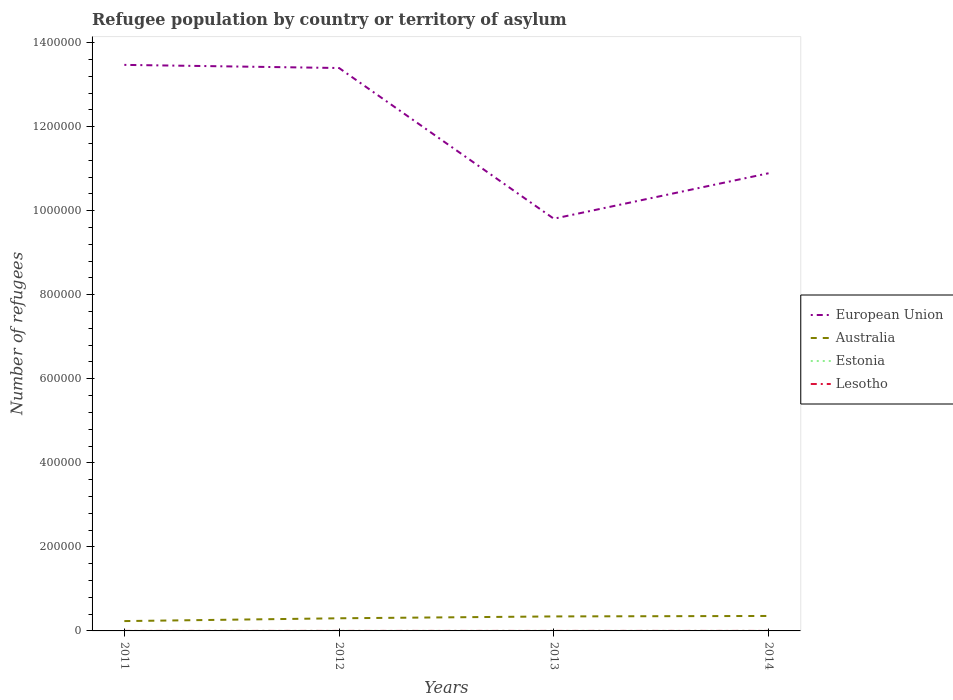How many different coloured lines are there?
Your answer should be very brief. 4. Does the line corresponding to Lesotho intersect with the line corresponding to European Union?
Provide a short and direct response. No. Across all years, what is the maximum number of refugees in European Union?
Give a very brief answer. 9.81e+05. In which year was the number of refugees in Estonia maximum?
Offer a terse response. 2011. What is the total number of refugees in Australia in the graph?
Offer a terse response. -6649. What is the difference between the highest and the lowest number of refugees in Lesotho?
Make the answer very short. 1. Is the number of refugees in Estonia strictly greater than the number of refugees in Lesotho over the years?
Offer a very short reply. No. How many lines are there?
Offer a very short reply. 4. Are the values on the major ticks of Y-axis written in scientific E-notation?
Your answer should be compact. No. Does the graph contain any zero values?
Make the answer very short. No. How many legend labels are there?
Provide a succinct answer. 4. How are the legend labels stacked?
Ensure brevity in your answer.  Vertical. What is the title of the graph?
Provide a succinct answer. Refugee population by country or territory of asylum. What is the label or title of the Y-axis?
Your answer should be compact. Number of refugees. What is the Number of refugees of European Union in 2011?
Give a very brief answer. 1.35e+06. What is the Number of refugees of Australia in 2011?
Your answer should be compact. 2.34e+04. What is the Number of refugees in Estonia in 2011?
Ensure brevity in your answer.  50. What is the Number of refugees of Lesotho in 2011?
Offer a very short reply. 34. What is the Number of refugees in European Union in 2012?
Your answer should be compact. 1.34e+06. What is the Number of refugees of Australia in 2012?
Ensure brevity in your answer.  3.01e+04. What is the Number of refugees in Estonia in 2012?
Offer a very short reply. 63. What is the Number of refugees of Lesotho in 2012?
Your answer should be compact. 34. What is the Number of refugees of European Union in 2013?
Your answer should be compact. 9.81e+05. What is the Number of refugees in Australia in 2013?
Make the answer very short. 3.45e+04. What is the Number of refugees in Estonia in 2013?
Provide a short and direct response. 70. What is the Number of refugees in European Union in 2014?
Ensure brevity in your answer.  1.09e+06. What is the Number of refugees of Australia in 2014?
Make the answer very short. 3.56e+04. Across all years, what is the maximum Number of refugees in European Union?
Provide a short and direct response. 1.35e+06. Across all years, what is the maximum Number of refugees of Australia?
Offer a terse response. 3.56e+04. Across all years, what is the minimum Number of refugees of European Union?
Provide a short and direct response. 9.81e+05. Across all years, what is the minimum Number of refugees in Australia?
Ensure brevity in your answer.  2.34e+04. What is the total Number of refugees in European Union in the graph?
Your answer should be compact. 4.76e+06. What is the total Number of refugees in Australia in the graph?
Your answer should be very brief. 1.24e+05. What is the total Number of refugees of Estonia in the graph?
Offer a very short reply. 273. What is the total Number of refugees of Lesotho in the graph?
Make the answer very short. 142. What is the difference between the Number of refugees in European Union in 2011 and that in 2012?
Keep it short and to the point. 7465. What is the difference between the Number of refugees of Australia in 2011 and that in 2012?
Make the answer very short. -6649. What is the difference between the Number of refugees of Estonia in 2011 and that in 2012?
Provide a succinct answer. -13. What is the difference between the Number of refugees of European Union in 2011 and that in 2013?
Offer a terse response. 3.66e+05. What is the difference between the Number of refugees of Australia in 2011 and that in 2013?
Your answer should be very brief. -1.11e+04. What is the difference between the Number of refugees of Lesotho in 2011 and that in 2013?
Give a very brief answer. 4. What is the difference between the Number of refugees of European Union in 2011 and that in 2014?
Offer a terse response. 2.58e+05. What is the difference between the Number of refugees in Australia in 2011 and that in 2014?
Ensure brevity in your answer.  -1.21e+04. What is the difference between the Number of refugees in Estonia in 2011 and that in 2014?
Offer a very short reply. -40. What is the difference between the Number of refugees of Lesotho in 2011 and that in 2014?
Your answer should be compact. -10. What is the difference between the Number of refugees of European Union in 2012 and that in 2013?
Keep it short and to the point. 3.59e+05. What is the difference between the Number of refugees in Australia in 2012 and that in 2013?
Provide a short and direct response. -4420. What is the difference between the Number of refugees of European Union in 2012 and that in 2014?
Provide a succinct answer. 2.50e+05. What is the difference between the Number of refugees in Australia in 2012 and that in 2014?
Give a very brief answer. -5499. What is the difference between the Number of refugees of European Union in 2013 and that in 2014?
Keep it short and to the point. -1.08e+05. What is the difference between the Number of refugees of Australia in 2013 and that in 2014?
Offer a very short reply. -1079. What is the difference between the Number of refugees in European Union in 2011 and the Number of refugees in Australia in 2012?
Make the answer very short. 1.32e+06. What is the difference between the Number of refugees of European Union in 2011 and the Number of refugees of Estonia in 2012?
Your answer should be compact. 1.35e+06. What is the difference between the Number of refugees of European Union in 2011 and the Number of refugees of Lesotho in 2012?
Your answer should be very brief. 1.35e+06. What is the difference between the Number of refugees of Australia in 2011 and the Number of refugees of Estonia in 2012?
Offer a very short reply. 2.34e+04. What is the difference between the Number of refugees in Australia in 2011 and the Number of refugees in Lesotho in 2012?
Make the answer very short. 2.34e+04. What is the difference between the Number of refugees in European Union in 2011 and the Number of refugees in Australia in 2013?
Provide a succinct answer. 1.31e+06. What is the difference between the Number of refugees of European Union in 2011 and the Number of refugees of Estonia in 2013?
Provide a succinct answer. 1.35e+06. What is the difference between the Number of refugees of European Union in 2011 and the Number of refugees of Lesotho in 2013?
Your answer should be very brief. 1.35e+06. What is the difference between the Number of refugees in Australia in 2011 and the Number of refugees in Estonia in 2013?
Give a very brief answer. 2.34e+04. What is the difference between the Number of refugees of Australia in 2011 and the Number of refugees of Lesotho in 2013?
Give a very brief answer. 2.34e+04. What is the difference between the Number of refugees in European Union in 2011 and the Number of refugees in Australia in 2014?
Ensure brevity in your answer.  1.31e+06. What is the difference between the Number of refugees in European Union in 2011 and the Number of refugees in Estonia in 2014?
Offer a terse response. 1.35e+06. What is the difference between the Number of refugees of European Union in 2011 and the Number of refugees of Lesotho in 2014?
Provide a succinct answer. 1.35e+06. What is the difference between the Number of refugees in Australia in 2011 and the Number of refugees in Estonia in 2014?
Provide a short and direct response. 2.33e+04. What is the difference between the Number of refugees of Australia in 2011 and the Number of refugees of Lesotho in 2014?
Your answer should be compact. 2.34e+04. What is the difference between the Number of refugees in European Union in 2012 and the Number of refugees in Australia in 2013?
Offer a terse response. 1.31e+06. What is the difference between the Number of refugees of European Union in 2012 and the Number of refugees of Estonia in 2013?
Provide a short and direct response. 1.34e+06. What is the difference between the Number of refugees in European Union in 2012 and the Number of refugees in Lesotho in 2013?
Give a very brief answer. 1.34e+06. What is the difference between the Number of refugees of Australia in 2012 and the Number of refugees of Estonia in 2013?
Keep it short and to the point. 3.00e+04. What is the difference between the Number of refugees in Australia in 2012 and the Number of refugees in Lesotho in 2013?
Your response must be concise. 3.01e+04. What is the difference between the Number of refugees in European Union in 2012 and the Number of refugees in Australia in 2014?
Ensure brevity in your answer.  1.30e+06. What is the difference between the Number of refugees in European Union in 2012 and the Number of refugees in Estonia in 2014?
Ensure brevity in your answer.  1.34e+06. What is the difference between the Number of refugees in European Union in 2012 and the Number of refugees in Lesotho in 2014?
Provide a succinct answer. 1.34e+06. What is the difference between the Number of refugees of Australia in 2012 and the Number of refugees of Estonia in 2014?
Make the answer very short. 3.00e+04. What is the difference between the Number of refugees of Australia in 2012 and the Number of refugees of Lesotho in 2014?
Make the answer very short. 3.00e+04. What is the difference between the Number of refugees of Estonia in 2012 and the Number of refugees of Lesotho in 2014?
Offer a very short reply. 19. What is the difference between the Number of refugees of European Union in 2013 and the Number of refugees of Australia in 2014?
Keep it short and to the point. 9.45e+05. What is the difference between the Number of refugees in European Union in 2013 and the Number of refugees in Estonia in 2014?
Your answer should be compact. 9.81e+05. What is the difference between the Number of refugees of European Union in 2013 and the Number of refugees of Lesotho in 2014?
Keep it short and to the point. 9.81e+05. What is the difference between the Number of refugees in Australia in 2013 and the Number of refugees in Estonia in 2014?
Provide a succinct answer. 3.44e+04. What is the difference between the Number of refugees in Australia in 2013 and the Number of refugees in Lesotho in 2014?
Your answer should be very brief. 3.45e+04. What is the difference between the Number of refugees in Estonia in 2013 and the Number of refugees in Lesotho in 2014?
Give a very brief answer. 26. What is the average Number of refugees of European Union per year?
Provide a short and direct response. 1.19e+06. What is the average Number of refugees in Australia per year?
Give a very brief answer. 3.09e+04. What is the average Number of refugees of Estonia per year?
Your answer should be very brief. 68.25. What is the average Number of refugees in Lesotho per year?
Your response must be concise. 35.5. In the year 2011, what is the difference between the Number of refugees in European Union and Number of refugees in Australia?
Provide a succinct answer. 1.32e+06. In the year 2011, what is the difference between the Number of refugees in European Union and Number of refugees in Estonia?
Offer a very short reply. 1.35e+06. In the year 2011, what is the difference between the Number of refugees in European Union and Number of refugees in Lesotho?
Your answer should be compact. 1.35e+06. In the year 2011, what is the difference between the Number of refugees in Australia and Number of refugees in Estonia?
Give a very brief answer. 2.34e+04. In the year 2011, what is the difference between the Number of refugees in Australia and Number of refugees in Lesotho?
Ensure brevity in your answer.  2.34e+04. In the year 2011, what is the difference between the Number of refugees of Estonia and Number of refugees of Lesotho?
Provide a succinct answer. 16. In the year 2012, what is the difference between the Number of refugees in European Union and Number of refugees in Australia?
Offer a terse response. 1.31e+06. In the year 2012, what is the difference between the Number of refugees in European Union and Number of refugees in Estonia?
Provide a short and direct response. 1.34e+06. In the year 2012, what is the difference between the Number of refugees in European Union and Number of refugees in Lesotho?
Your answer should be very brief. 1.34e+06. In the year 2012, what is the difference between the Number of refugees in Australia and Number of refugees in Estonia?
Your answer should be very brief. 3.00e+04. In the year 2012, what is the difference between the Number of refugees in Australia and Number of refugees in Lesotho?
Ensure brevity in your answer.  3.00e+04. In the year 2012, what is the difference between the Number of refugees in Estonia and Number of refugees in Lesotho?
Keep it short and to the point. 29. In the year 2013, what is the difference between the Number of refugees in European Union and Number of refugees in Australia?
Provide a succinct answer. 9.46e+05. In the year 2013, what is the difference between the Number of refugees of European Union and Number of refugees of Estonia?
Ensure brevity in your answer.  9.81e+05. In the year 2013, what is the difference between the Number of refugees of European Union and Number of refugees of Lesotho?
Keep it short and to the point. 9.81e+05. In the year 2013, what is the difference between the Number of refugees of Australia and Number of refugees of Estonia?
Provide a short and direct response. 3.44e+04. In the year 2013, what is the difference between the Number of refugees in Australia and Number of refugees in Lesotho?
Give a very brief answer. 3.45e+04. In the year 2014, what is the difference between the Number of refugees in European Union and Number of refugees in Australia?
Offer a very short reply. 1.05e+06. In the year 2014, what is the difference between the Number of refugees of European Union and Number of refugees of Estonia?
Give a very brief answer. 1.09e+06. In the year 2014, what is the difference between the Number of refugees in European Union and Number of refugees in Lesotho?
Your answer should be compact. 1.09e+06. In the year 2014, what is the difference between the Number of refugees of Australia and Number of refugees of Estonia?
Make the answer very short. 3.55e+04. In the year 2014, what is the difference between the Number of refugees of Australia and Number of refugees of Lesotho?
Your answer should be very brief. 3.55e+04. What is the ratio of the Number of refugees in European Union in 2011 to that in 2012?
Make the answer very short. 1.01. What is the ratio of the Number of refugees in Australia in 2011 to that in 2012?
Offer a very short reply. 0.78. What is the ratio of the Number of refugees of Estonia in 2011 to that in 2012?
Your answer should be compact. 0.79. What is the ratio of the Number of refugees in European Union in 2011 to that in 2013?
Provide a short and direct response. 1.37. What is the ratio of the Number of refugees of Australia in 2011 to that in 2013?
Your response must be concise. 0.68. What is the ratio of the Number of refugees in Lesotho in 2011 to that in 2013?
Offer a very short reply. 1.13. What is the ratio of the Number of refugees in European Union in 2011 to that in 2014?
Your answer should be compact. 1.24. What is the ratio of the Number of refugees of Australia in 2011 to that in 2014?
Provide a short and direct response. 0.66. What is the ratio of the Number of refugees in Estonia in 2011 to that in 2014?
Your answer should be very brief. 0.56. What is the ratio of the Number of refugees of Lesotho in 2011 to that in 2014?
Your response must be concise. 0.77. What is the ratio of the Number of refugees in European Union in 2012 to that in 2013?
Provide a short and direct response. 1.37. What is the ratio of the Number of refugees of Australia in 2012 to that in 2013?
Provide a short and direct response. 0.87. What is the ratio of the Number of refugees of Estonia in 2012 to that in 2013?
Give a very brief answer. 0.9. What is the ratio of the Number of refugees in Lesotho in 2012 to that in 2013?
Your answer should be compact. 1.13. What is the ratio of the Number of refugees of European Union in 2012 to that in 2014?
Keep it short and to the point. 1.23. What is the ratio of the Number of refugees in Australia in 2012 to that in 2014?
Your answer should be compact. 0.85. What is the ratio of the Number of refugees in Estonia in 2012 to that in 2014?
Provide a short and direct response. 0.7. What is the ratio of the Number of refugees in Lesotho in 2012 to that in 2014?
Your answer should be compact. 0.77. What is the ratio of the Number of refugees of European Union in 2013 to that in 2014?
Your answer should be very brief. 0.9. What is the ratio of the Number of refugees of Australia in 2013 to that in 2014?
Offer a very short reply. 0.97. What is the ratio of the Number of refugees of Lesotho in 2013 to that in 2014?
Keep it short and to the point. 0.68. What is the difference between the highest and the second highest Number of refugees in European Union?
Keep it short and to the point. 7465. What is the difference between the highest and the second highest Number of refugees in Australia?
Provide a succinct answer. 1079. What is the difference between the highest and the second highest Number of refugees in Lesotho?
Give a very brief answer. 10. What is the difference between the highest and the lowest Number of refugees of European Union?
Ensure brevity in your answer.  3.66e+05. What is the difference between the highest and the lowest Number of refugees of Australia?
Your answer should be very brief. 1.21e+04. What is the difference between the highest and the lowest Number of refugees of Estonia?
Make the answer very short. 40. 